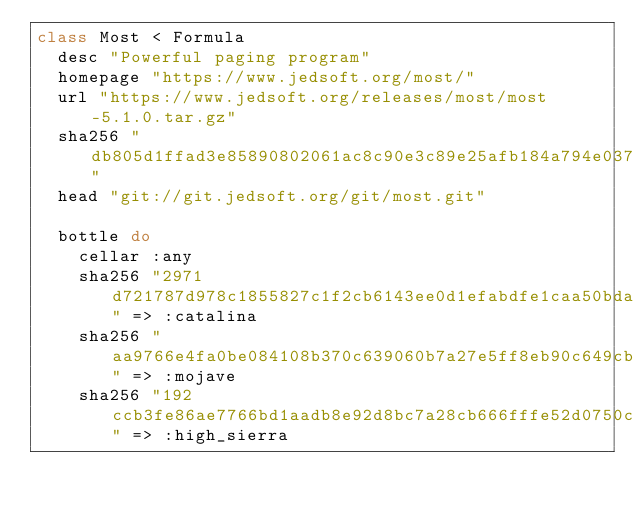Convert code to text. <code><loc_0><loc_0><loc_500><loc_500><_Ruby_>class Most < Formula
  desc "Powerful paging program"
  homepage "https://www.jedsoft.org/most/"
  url "https://www.jedsoft.org/releases/most/most-5.1.0.tar.gz"
  sha256 "db805d1ffad3e85890802061ac8c90e3c89e25afb184a794e03715a3ed190501"
  head "git://git.jedsoft.org/git/most.git"

  bottle do
    cellar :any
    sha256 "2971d721787d978c1855827c1f2cb6143ee0d1efabdfe1caa50bda981865a24d" => :catalina
    sha256 "aa9766e4fa0be084108b370c639060b7a27e5ff8eb90c649cbc643160659932f" => :mojave
    sha256 "192ccb3fe86ae7766bd1aadb8e92d8bc7a28cb666fffe52d0750c6c2a4450657" => :high_sierra</code> 